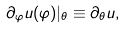Convert formula to latex. <formula><loc_0><loc_0><loc_500><loc_500>\partial _ { \varphi } u ( \varphi ) | _ { \theta } \equiv \partial _ { \theta } u ,</formula> 